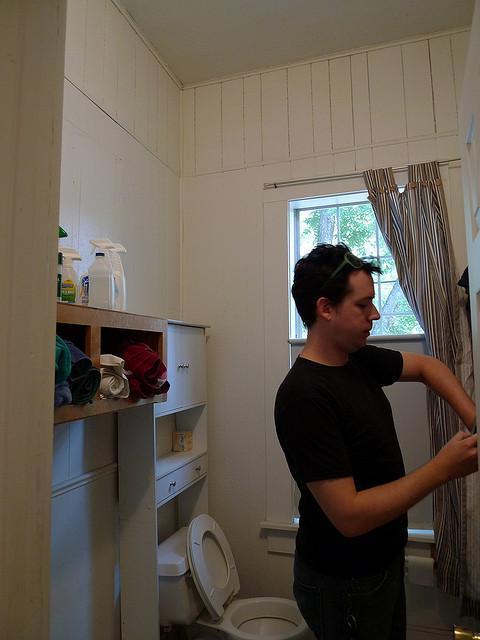How many people are in the picture?
Give a very brief answer. 1. How many cabinets?
Give a very brief answer. 2. How many orange trucks are there?
Give a very brief answer. 0. 